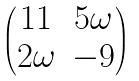Convert formula to latex. <formula><loc_0><loc_0><loc_500><loc_500>\begin{pmatrix} 1 1 & 5 \omega \\ 2 \omega & - 9 \end{pmatrix}</formula> 